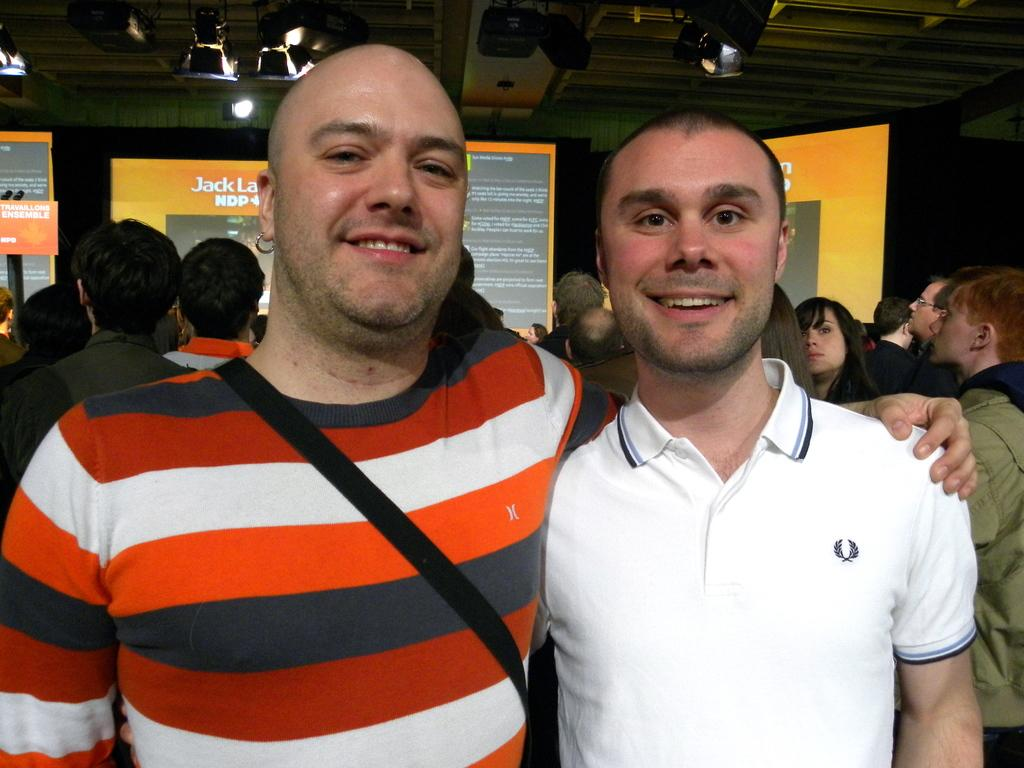<image>
Write a terse but informative summary of the picture. Two men are next to each other posing for the camera and the name of Jack can be seen behind them. 